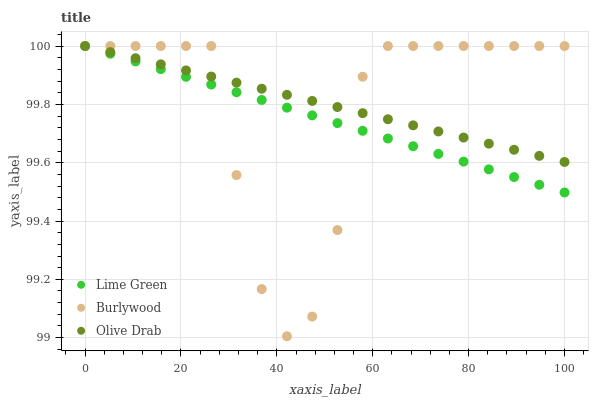Does Lime Green have the minimum area under the curve?
Answer yes or no. Yes. Does Olive Drab have the maximum area under the curve?
Answer yes or no. Yes. Does Olive Drab have the minimum area under the curve?
Answer yes or no. No. Does Lime Green have the maximum area under the curve?
Answer yes or no. No. Is Olive Drab the smoothest?
Answer yes or no. Yes. Is Burlywood the roughest?
Answer yes or no. Yes. Is Lime Green the smoothest?
Answer yes or no. No. Is Lime Green the roughest?
Answer yes or no. No. Does Burlywood have the lowest value?
Answer yes or no. Yes. Does Lime Green have the lowest value?
Answer yes or no. No. Does Olive Drab have the highest value?
Answer yes or no. Yes. Does Burlywood intersect Olive Drab?
Answer yes or no. Yes. Is Burlywood less than Olive Drab?
Answer yes or no. No. Is Burlywood greater than Olive Drab?
Answer yes or no. No. 